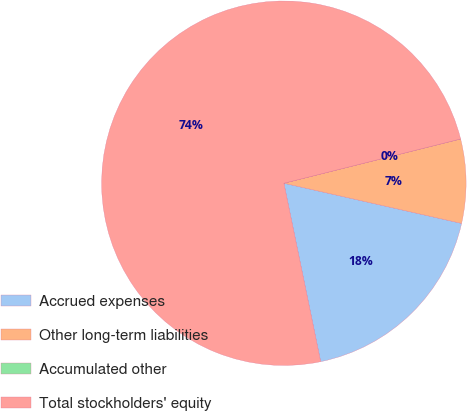<chart> <loc_0><loc_0><loc_500><loc_500><pie_chart><fcel>Accrued expenses<fcel>Other long-term liabilities<fcel>Accumulated other<fcel>Total stockholders' equity<nl><fcel>18.22%<fcel>7.44%<fcel>0.01%<fcel>74.32%<nl></chart> 